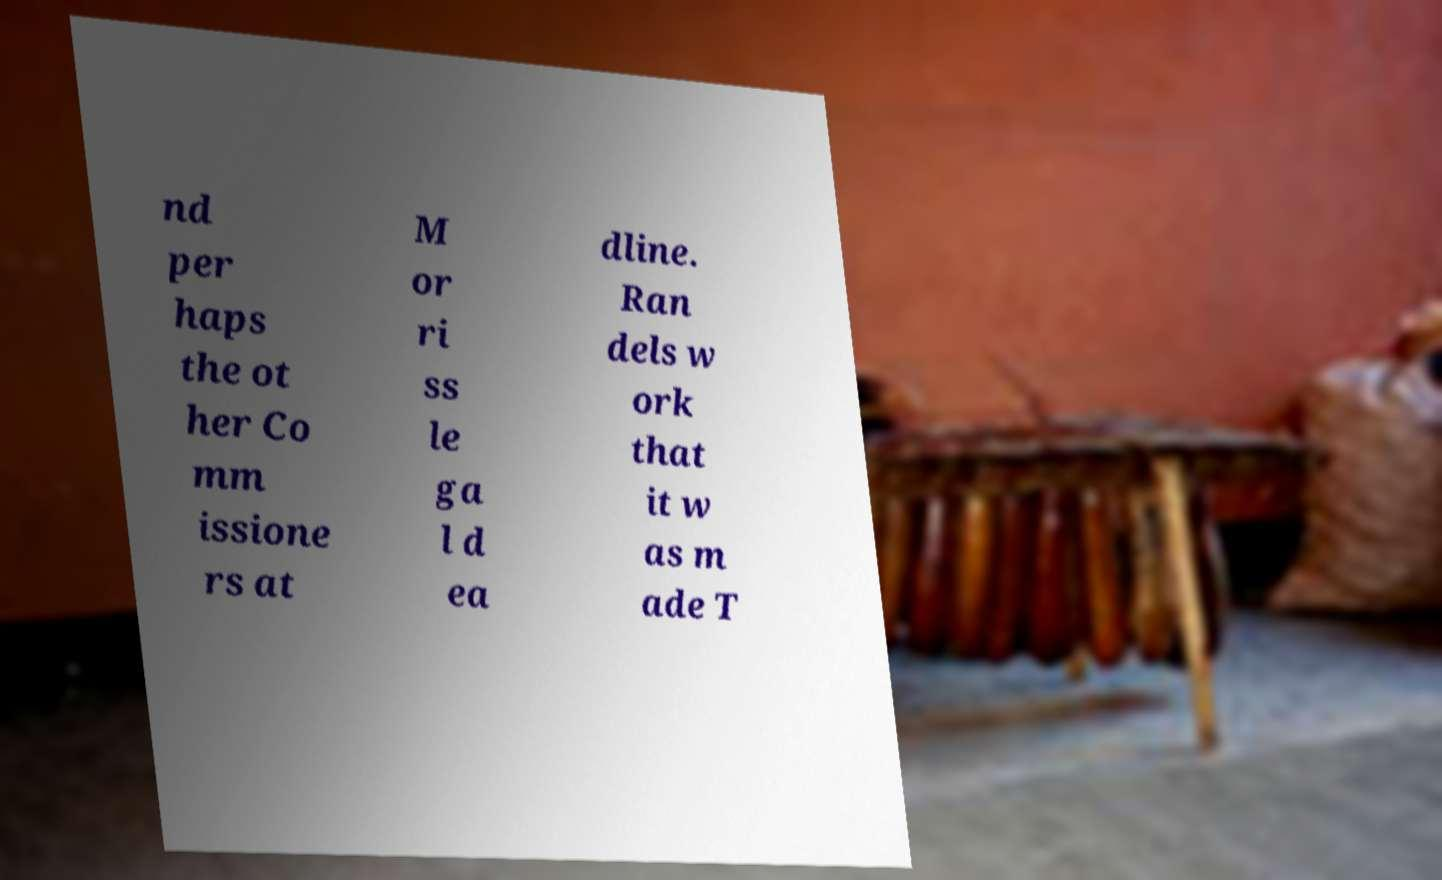For documentation purposes, I need the text within this image transcribed. Could you provide that? nd per haps the ot her Co mm issione rs at M or ri ss le ga l d ea dline. Ran dels w ork that it w as m ade T 